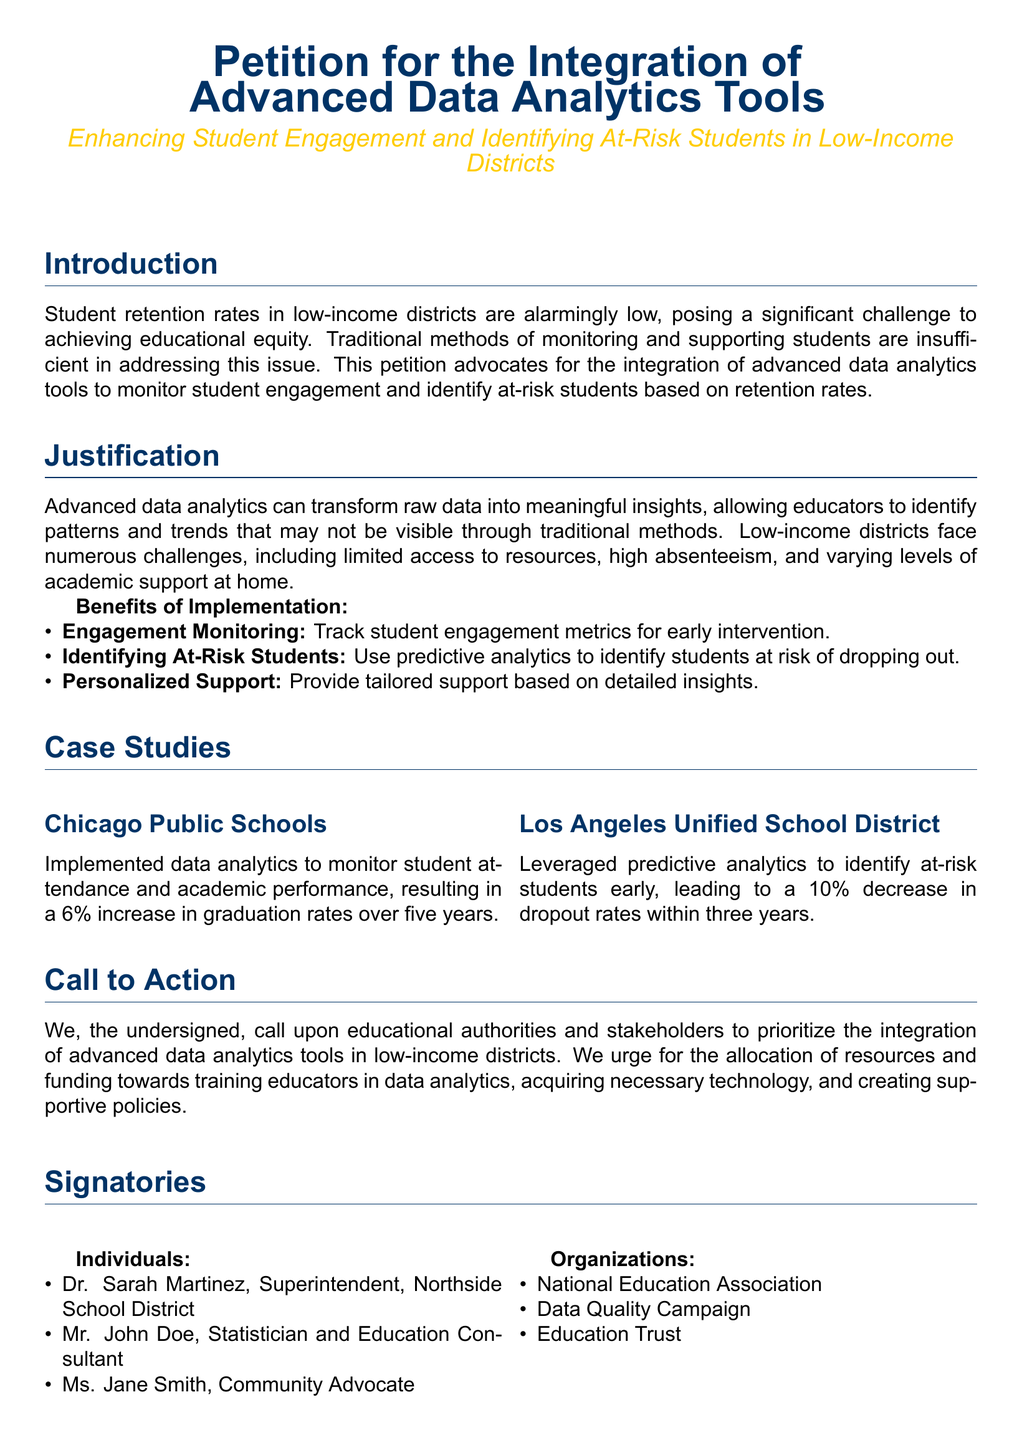What is the main purpose of the petition? The petition advocates for the integration of advanced data analytics tools to monitor student engagement and identify at-risk students based on retention rates.
Answer: Integration of advanced data analytics tools Who is one of the signers listed as a Community Advocate? Ms. Jane Smith is mentioned as one of the individuals in the signatories section of the document.
Answer: Ms. Jane Smith What percentage increase in graduation rates did Chicago Public Schools achieve? The document states that Chicago Public Schools experienced a 6% increase in graduation rates over five years due to implementing data analytics.
Answer: 6% Which district achieved a 10% decrease in dropout rates? The Los Angeles Unified School District is credited with this achievement within three years of leveraging predictive analytics.
Answer: Los Angeles Unified School District What is one of the benefits of implementing data analytics tools mentioned in the petition? The document lists several benefits, including tracking student engagement metrics for early intervention.
Answer: Engagement Monitoring What type of challenges do low-income districts face according to the document? The document highlights challenges such as limited access to resources, high absenteeism, and varying levels of academic support at home.
Answer: Limited access to resources What is the call to action in the petition? The petition urges educational authorities and stakeholders to prioritize the integration of advanced data analytics tools in low-income districts.
Answer: Prioritize integration of advanced data analytics tools What is the color used for the main title of the document? The main title of the document is presented in a specific shade of blue defined as RGB(0,51,102).
Answer: Blue What organization is listed as one of the signatories? The National Education Association is one of the organizations listed in the signatories section.
Answer: National Education Association 